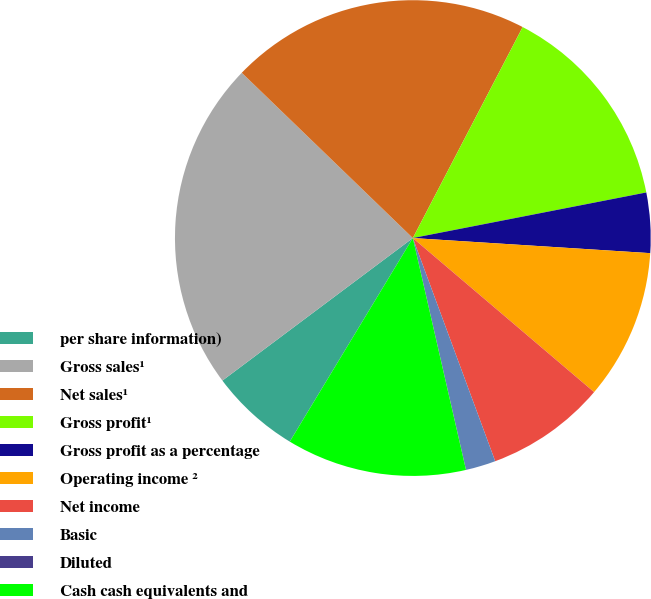Convert chart. <chart><loc_0><loc_0><loc_500><loc_500><pie_chart><fcel>per share information)<fcel>Gross sales¹<fcel>Net sales¹<fcel>Gross profit¹<fcel>Gross profit as a percentage<fcel>Operating income ²<fcel>Net income<fcel>Basic<fcel>Diluted<fcel>Cash cash equivalents and<nl><fcel>6.12%<fcel>22.45%<fcel>20.41%<fcel>14.29%<fcel>4.08%<fcel>10.2%<fcel>8.16%<fcel>2.04%<fcel>0.0%<fcel>12.24%<nl></chart> 